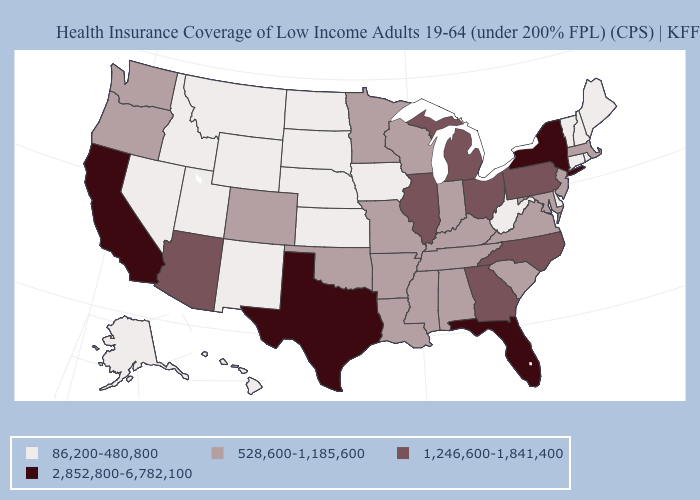What is the value of Wyoming?
Quick response, please. 86,200-480,800. Does the map have missing data?
Give a very brief answer. No. What is the highest value in the USA?
Quick response, please. 2,852,800-6,782,100. Does Iowa have the lowest value in the MidWest?
Short answer required. Yes. Does Virginia have a higher value than Ohio?
Keep it brief. No. Name the states that have a value in the range 86,200-480,800?
Write a very short answer. Alaska, Connecticut, Delaware, Hawaii, Idaho, Iowa, Kansas, Maine, Montana, Nebraska, Nevada, New Hampshire, New Mexico, North Dakota, Rhode Island, South Dakota, Utah, Vermont, West Virginia, Wyoming. Does the map have missing data?
Give a very brief answer. No. Does Rhode Island have the same value as Illinois?
Answer briefly. No. Is the legend a continuous bar?
Keep it brief. No. Is the legend a continuous bar?
Concise answer only. No. What is the highest value in the South ?
Give a very brief answer. 2,852,800-6,782,100. What is the highest value in states that border Massachusetts?
Concise answer only. 2,852,800-6,782,100. Which states have the highest value in the USA?
Write a very short answer. California, Florida, New York, Texas. Does the first symbol in the legend represent the smallest category?
Answer briefly. Yes. What is the lowest value in the USA?
Answer briefly. 86,200-480,800. 